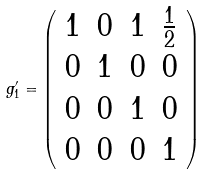Convert formula to latex. <formula><loc_0><loc_0><loc_500><loc_500>g ^ { \prime } _ { 1 } = \left ( \begin{array} { c c c c } 1 & 0 & 1 & \frac { 1 } { 2 } \\ 0 & 1 & 0 & 0 \\ 0 & 0 & 1 & 0 \\ 0 & 0 & 0 & 1 \end{array} \right )</formula> 